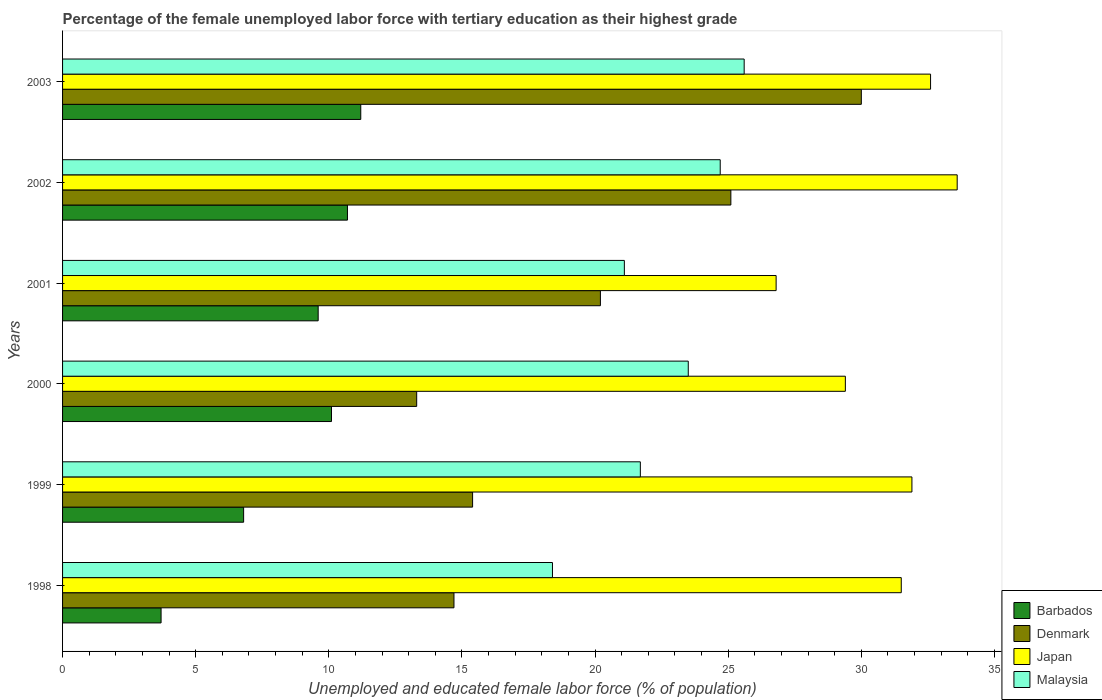How many different coloured bars are there?
Your answer should be compact. 4. Are the number of bars on each tick of the Y-axis equal?
Your response must be concise. Yes. How many bars are there on the 2nd tick from the top?
Offer a very short reply. 4. How many bars are there on the 2nd tick from the bottom?
Ensure brevity in your answer.  4. What is the percentage of the unemployed female labor force with tertiary education in Malaysia in 2003?
Make the answer very short. 25.6. Across all years, what is the maximum percentage of the unemployed female labor force with tertiary education in Japan?
Your answer should be very brief. 33.6. Across all years, what is the minimum percentage of the unemployed female labor force with tertiary education in Malaysia?
Offer a terse response. 18.4. In which year was the percentage of the unemployed female labor force with tertiary education in Denmark minimum?
Provide a short and direct response. 2000. What is the total percentage of the unemployed female labor force with tertiary education in Malaysia in the graph?
Give a very brief answer. 135. What is the difference between the percentage of the unemployed female labor force with tertiary education in Barbados in 2000 and that in 2003?
Keep it short and to the point. -1.1. What is the difference between the percentage of the unemployed female labor force with tertiary education in Japan in 2001 and the percentage of the unemployed female labor force with tertiary education in Denmark in 2003?
Offer a terse response. -3.2. What is the average percentage of the unemployed female labor force with tertiary education in Barbados per year?
Provide a short and direct response. 8.68. In the year 2002, what is the difference between the percentage of the unemployed female labor force with tertiary education in Denmark and percentage of the unemployed female labor force with tertiary education in Japan?
Your answer should be compact. -8.5. In how many years, is the percentage of the unemployed female labor force with tertiary education in Japan greater than 25 %?
Offer a very short reply. 6. What is the ratio of the percentage of the unemployed female labor force with tertiary education in Malaysia in 1999 to that in 2000?
Offer a very short reply. 0.92. What is the difference between the highest and the second highest percentage of the unemployed female labor force with tertiary education in Barbados?
Provide a short and direct response. 0.5. What is the difference between the highest and the lowest percentage of the unemployed female labor force with tertiary education in Barbados?
Your response must be concise. 7.5. In how many years, is the percentage of the unemployed female labor force with tertiary education in Denmark greater than the average percentage of the unemployed female labor force with tertiary education in Denmark taken over all years?
Provide a short and direct response. 3. Is the sum of the percentage of the unemployed female labor force with tertiary education in Barbados in 2001 and 2002 greater than the maximum percentage of the unemployed female labor force with tertiary education in Denmark across all years?
Offer a very short reply. No. Is it the case that in every year, the sum of the percentage of the unemployed female labor force with tertiary education in Barbados and percentage of the unemployed female labor force with tertiary education in Denmark is greater than the sum of percentage of the unemployed female labor force with tertiary education in Malaysia and percentage of the unemployed female labor force with tertiary education in Japan?
Make the answer very short. No. What does the 2nd bar from the bottom in 1999 represents?
Make the answer very short. Denmark. How many bars are there?
Your answer should be very brief. 24. Are all the bars in the graph horizontal?
Keep it short and to the point. Yes. What is the difference between two consecutive major ticks on the X-axis?
Offer a terse response. 5. Are the values on the major ticks of X-axis written in scientific E-notation?
Make the answer very short. No. Does the graph contain grids?
Your answer should be very brief. No. Where does the legend appear in the graph?
Keep it short and to the point. Bottom right. What is the title of the graph?
Your answer should be very brief. Percentage of the female unemployed labor force with tertiary education as their highest grade. What is the label or title of the X-axis?
Offer a very short reply. Unemployed and educated female labor force (% of population). What is the label or title of the Y-axis?
Keep it short and to the point. Years. What is the Unemployed and educated female labor force (% of population) of Barbados in 1998?
Your answer should be compact. 3.7. What is the Unemployed and educated female labor force (% of population) of Denmark in 1998?
Make the answer very short. 14.7. What is the Unemployed and educated female labor force (% of population) in Japan in 1998?
Your response must be concise. 31.5. What is the Unemployed and educated female labor force (% of population) of Malaysia in 1998?
Your answer should be compact. 18.4. What is the Unemployed and educated female labor force (% of population) of Barbados in 1999?
Your answer should be compact. 6.8. What is the Unemployed and educated female labor force (% of population) of Denmark in 1999?
Offer a terse response. 15.4. What is the Unemployed and educated female labor force (% of population) of Japan in 1999?
Provide a short and direct response. 31.9. What is the Unemployed and educated female labor force (% of population) of Malaysia in 1999?
Make the answer very short. 21.7. What is the Unemployed and educated female labor force (% of population) of Barbados in 2000?
Give a very brief answer. 10.1. What is the Unemployed and educated female labor force (% of population) in Denmark in 2000?
Your answer should be very brief. 13.3. What is the Unemployed and educated female labor force (% of population) of Japan in 2000?
Offer a terse response. 29.4. What is the Unemployed and educated female labor force (% of population) of Malaysia in 2000?
Your answer should be very brief. 23.5. What is the Unemployed and educated female labor force (% of population) of Barbados in 2001?
Offer a very short reply. 9.6. What is the Unemployed and educated female labor force (% of population) of Denmark in 2001?
Your answer should be compact. 20.2. What is the Unemployed and educated female labor force (% of population) in Japan in 2001?
Ensure brevity in your answer.  26.8. What is the Unemployed and educated female labor force (% of population) in Malaysia in 2001?
Provide a short and direct response. 21.1. What is the Unemployed and educated female labor force (% of population) of Barbados in 2002?
Your answer should be very brief. 10.7. What is the Unemployed and educated female labor force (% of population) of Denmark in 2002?
Provide a short and direct response. 25.1. What is the Unemployed and educated female labor force (% of population) in Japan in 2002?
Your response must be concise. 33.6. What is the Unemployed and educated female labor force (% of population) of Malaysia in 2002?
Offer a very short reply. 24.7. What is the Unemployed and educated female labor force (% of population) of Barbados in 2003?
Your answer should be compact. 11.2. What is the Unemployed and educated female labor force (% of population) of Denmark in 2003?
Make the answer very short. 30. What is the Unemployed and educated female labor force (% of population) in Japan in 2003?
Give a very brief answer. 32.6. What is the Unemployed and educated female labor force (% of population) in Malaysia in 2003?
Provide a short and direct response. 25.6. Across all years, what is the maximum Unemployed and educated female labor force (% of population) in Barbados?
Offer a terse response. 11.2. Across all years, what is the maximum Unemployed and educated female labor force (% of population) of Denmark?
Give a very brief answer. 30. Across all years, what is the maximum Unemployed and educated female labor force (% of population) of Japan?
Give a very brief answer. 33.6. Across all years, what is the maximum Unemployed and educated female labor force (% of population) of Malaysia?
Ensure brevity in your answer.  25.6. Across all years, what is the minimum Unemployed and educated female labor force (% of population) of Barbados?
Your response must be concise. 3.7. Across all years, what is the minimum Unemployed and educated female labor force (% of population) of Denmark?
Your answer should be very brief. 13.3. Across all years, what is the minimum Unemployed and educated female labor force (% of population) of Japan?
Give a very brief answer. 26.8. Across all years, what is the minimum Unemployed and educated female labor force (% of population) in Malaysia?
Your answer should be compact. 18.4. What is the total Unemployed and educated female labor force (% of population) in Barbados in the graph?
Provide a succinct answer. 52.1. What is the total Unemployed and educated female labor force (% of population) in Denmark in the graph?
Your response must be concise. 118.7. What is the total Unemployed and educated female labor force (% of population) of Japan in the graph?
Your response must be concise. 185.8. What is the total Unemployed and educated female labor force (% of population) in Malaysia in the graph?
Your response must be concise. 135. What is the difference between the Unemployed and educated female labor force (% of population) in Denmark in 1998 and that in 1999?
Your answer should be compact. -0.7. What is the difference between the Unemployed and educated female labor force (% of population) in Japan in 1998 and that in 1999?
Give a very brief answer. -0.4. What is the difference between the Unemployed and educated female labor force (% of population) in Barbados in 1998 and that in 2000?
Provide a short and direct response. -6.4. What is the difference between the Unemployed and educated female labor force (% of population) of Denmark in 1998 and that in 2000?
Give a very brief answer. 1.4. What is the difference between the Unemployed and educated female labor force (% of population) of Malaysia in 1998 and that in 2000?
Ensure brevity in your answer.  -5.1. What is the difference between the Unemployed and educated female labor force (% of population) in Denmark in 1998 and that in 2001?
Your answer should be compact. -5.5. What is the difference between the Unemployed and educated female labor force (% of population) in Japan in 1998 and that in 2001?
Make the answer very short. 4.7. What is the difference between the Unemployed and educated female labor force (% of population) of Malaysia in 1998 and that in 2001?
Your answer should be compact. -2.7. What is the difference between the Unemployed and educated female labor force (% of population) of Barbados in 1998 and that in 2002?
Offer a terse response. -7. What is the difference between the Unemployed and educated female labor force (% of population) in Denmark in 1998 and that in 2002?
Your answer should be compact. -10.4. What is the difference between the Unemployed and educated female labor force (% of population) of Japan in 1998 and that in 2002?
Offer a very short reply. -2.1. What is the difference between the Unemployed and educated female labor force (% of population) of Denmark in 1998 and that in 2003?
Ensure brevity in your answer.  -15.3. What is the difference between the Unemployed and educated female labor force (% of population) of Japan in 1999 and that in 2000?
Ensure brevity in your answer.  2.5. What is the difference between the Unemployed and educated female labor force (% of population) in Japan in 1999 and that in 2001?
Offer a terse response. 5.1. What is the difference between the Unemployed and educated female labor force (% of population) of Malaysia in 1999 and that in 2001?
Keep it short and to the point. 0.6. What is the difference between the Unemployed and educated female labor force (% of population) in Denmark in 1999 and that in 2002?
Ensure brevity in your answer.  -9.7. What is the difference between the Unemployed and educated female labor force (% of population) in Malaysia in 1999 and that in 2002?
Your answer should be compact. -3. What is the difference between the Unemployed and educated female labor force (% of population) in Barbados in 1999 and that in 2003?
Provide a short and direct response. -4.4. What is the difference between the Unemployed and educated female labor force (% of population) of Denmark in 1999 and that in 2003?
Give a very brief answer. -14.6. What is the difference between the Unemployed and educated female labor force (% of population) in Japan in 1999 and that in 2003?
Provide a succinct answer. -0.7. What is the difference between the Unemployed and educated female labor force (% of population) of Malaysia in 1999 and that in 2003?
Ensure brevity in your answer.  -3.9. What is the difference between the Unemployed and educated female labor force (% of population) in Denmark in 2000 and that in 2001?
Your answer should be compact. -6.9. What is the difference between the Unemployed and educated female labor force (% of population) in Japan in 2000 and that in 2001?
Ensure brevity in your answer.  2.6. What is the difference between the Unemployed and educated female labor force (% of population) in Malaysia in 2000 and that in 2001?
Your response must be concise. 2.4. What is the difference between the Unemployed and educated female labor force (% of population) of Denmark in 2000 and that in 2002?
Your response must be concise. -11.8. What is the difference between the Unemployed and educated female labor force (% of population) of Japan in 2000 and that in 2002?
Provide a short and direct response. -4.2. What is the difference between the Unemployed and educated female labor force (% of population) in Malaysia in 2000 and that in 2002?
Offer a terse response. -1.2. What is the difference between the Unemployed and educated female labor force (% of population) of Denmark in 2000 and that in 2003?
Ensure brevity in your answer.  -16.7. What is the difference between the Unemployed and educated female labor force (% of population) in Japan in 2000 and that in 2003?
Offer a very short reply. -3.2. What is the difference between the Unemployed and educated female labor force (% of population) in Malaysia in 2000 and that in 2003?
Keep it short and to the point. -2.1. What is the difference between the Unemployed and educated female labor force (% of population) of Barbados in 2001 and that in 2002?
Provide a short and direct response. -1.1. What is the difference between the Unemployed and educated female labor force (% of population) in Japan in 2001 and that in 2002?
Offer a terse response. -6.8. What is the difference between the Unemployed and educated female labor force (% of population) in Barbados in 2001 and that in 2003?
Your response must be concise. -1.6. What is the difference between the Unemployed and educated female labor force (% of population) in Denmark in 2001 and that in 2003?
Give a very brief answer. -9.8. What is the difference between the Unemployed and educated female labor force (% of population) in Malaysia in 2001 and that in 2003?
Make the answer very short. -4.5. What is the difference between the Unemployed and educated female labor force (% of population) in Barbados in 2002 and that in 2003?
Offer a terse response. -0.5. What is the difference between the Unemployed and educated female labor force (% of population) of Denmark in 2002 and that in 2003?
Keep it short and to the point. -4.9. What is the difference between the Unemployed and educated female labor force (% of population) of Barbados in 1998 and the Unemployed and educated female labor force (% of population) of Japan in 1999?
Your response must be concise. -28.2. What is the difference between the Unemployed and educated female labor force (% of population) of Denmark in 1998 and the Unemployed and educated female labor force (% of population) of Japan in 1999?
Provide a succinct answer. -17.2. What is the difference between the Unemployed and educated female labor force (% of population) in Japan in 1998 and the Unemployed and educated female labor force (% of population) in Malaysia in 1999?
Your answer should be very brief. 9.8. What is the difference between the Unemployed and educated female labor force (% of population) in Barbados in 1998 and the Unemployed and educated female labor force (% of population) in Japan in 2000?
Offer a terse response. -25.7. What is the difference between the Unemployed and educated female labor force (% of population) in Barbados in 1998 and the Unemployed and educated female labor force (% of population) in Malaysia in 2000?
Provide a succinct answer. -19.8. What is the difference between the Unemployed and educated female labor force (% of population) in Denmark in 1998 and the Unemployed and educated female labor force (% of population) in Japan in 2000?
Offer a very short reply. -14.7. What is the difference between the Unemployed and educated female labor force (% of population) in Japan in 1998 and the Unemployed and educated female labor force (% of population) in Malaysia in 2000?
Keep it short and to the point. 8. What is the difference between the Unemployed and educated female labor force (% of population) of Barbados in 1998 and the Unemployed and educated female labor force (% of population) of Denmark in 2001?
Give a very brief answer. -16.5. What is the difference between the Unemployed and educated female labor force (% of population) in Barbados in 1998 and the Unemployed and educated female labor force (% of population) in Japan in 2001?
Offer a very short reply. -23.1. What is the difference between the Unemployed and educated female labor force (% of population) in Barbados in 1998 and the Unemployed and educated female labor force (% of population) in Malaysia in 2001?
Make the answer very short. -17.4. What is the difference between the Unemployed and educated female labor force (% of population) in Japan in 1998 and the Unemployed and educated female labor force (% of population) in Malaysia in 2001?
Provide a succinct answer. 10.4. What is the difference between the Unemployed and educated female labor force (% of population) of Barbados in 1998 and the Unemployed and educated female labor force (% of population) of Denmark in 2002?
Your answer should be compact. -21.4. What is the difference between the Unemployed and educated female labor force (% of population) of Barbados in 1998 and the Unemployed and educated female labor force (% of population) of Japan in 2002?
Provide a short and direct response. -29.9. What is the difference between the Unemployed and educated female labor force (% of population) in Denmark in 1998 and the Unemployed and educated female labor force (% of population) in Japan in 2002?
Offer a very short reply. -18.9. What is the difference between the Unemployed and educated female labor force (% of population) in Japan in 1998 and the Unemployed and educated female labor force (% of population) in Malaysia in 2002?
Your answer should be compact. 6.8. What is the difference between the Unemployed and educated female labor force (% of population) in Barbados in 1998 and the Unemployed and educated female labor force (% of population) in Denmark in 2003?
Make the answer very short. -26.3. What is the difference between the Unemployed and educated female labor force (% of population) of Barbados in 1998 and the Unemployed and educated female labor force (% of population) of Japan in 2003?
Offer a terse response. -28.9. What is the difference between the Unemployed and educated female labor force (% of population) in Barbados in 1998 and the Unemployed and educated female labor force (% of population) in Malaysia in 2003?
Provide a short and direct response. -21.9. What is the difference between the Unemployed and educated female labor force (% of population) of Denmark in 1998 and the Unemployed and educated female labor force (% of population) of Japan in 2003?
Provide a succinct answer. -17.9. What is the difference between the Unemployed and educated female labor force (% of population) of Japan in 1998 and the Unemployed and educated female labor force (% of population) of Malaysia in 2003?
Provide a succinct answer. 5.9. What is the difference between the Unemployed and educated female labor force (% of population) of Barbados in 1999 and the Unemployed and educated female labor force (% of population) of Japan in 2000?
Offer a very short reply. -22.6. What is the difference between the Unemployed and educated female labor force (% of population) in Barbados in 1999 and the Unemployed and educated female labor force (% of population) in Malaysia in 2000?
Keep it short and to the point. -16.7. What is the difference between the Unemployed and educated female labor force (% of population) in Denmark in 1999 and the Unemployed and educated female labor force (% of population) in Japan in 2000?
Provide a short and direct response. -14. What is the difference between the Unemployed and educated female labor force (% of population) in Japan in 1999 and the Unemployed and educated female labor force (% of population) in Malaysia in 2000?
Your answer should be compact. 8.4. What is the difference between the Unemployed and educated female labor force (% of population) of Barbados in 1999 and the Unemployed and educated female labor force (% of population) of Japan in 2001?
Provide a short and direct response. -20. What is the difference between the Unemployed and educated female labor force (% of population) of Barbados in 1999 and the Unemployed and educated female labor force (% of population) of Malaysia in 2001?
Provide a succinct answer. -14.3. What is the difference between the Unemployed and educated female labor force (% of population) of Denmark in 1999 and the Unemployed and educated female labor force (% of population) of Japan in 2001?
Your answer should be very brief. -11.4. What is the difference between the Unemployed and educated female labor force (% of population) in Denmark in 1999 and the Unemployed and educated female labor force (% of population) in Malaysia in 2001?
Provide a short and direct response. -5.7. What is the difference between the Unemployed and educated female labor force (% of population) in Japan in 1999 and the Unemployed and educated female labor force (% of population) in Malaysia in 2001?
Make the answer very short. 10.8. What is the difference between the Unemployed and educated female labor force (% of population) of Barbados in 1999 and the Unemployed and educated female labor force (% of population) of Denmark in 2002?
Provide a short and direct response. -18.3. What is the difference between the Unemployed and educated female labor force (% of population) in Barbados in 1999 and the Unemployed and educated female labor force (% of population) in Japan in 2002?
Offer a terse response. -26.8. What is the difference between the Unemployed and educated female labor force (% of population) in Barbados in 1999 and the Unemployed and educated female labor force (% of population) in Malaysia in 2002?
Your answer should be compact. -17.9. What is the difference between the Unemployed and educated female labor force (% of population) of Denmark in 1999 and the Unemployed and educated female labor force (% of population) of Japan in 2002?
Your answer should be compact. -18.2. What is the difference between the Unemployed and educated female labor force (% of population) of Denmark in 1999 and the Unemployed and educated female labor force (% of population) of Malaysia in 2002?
Provide a succinct answer. -9.3. What is the difference between the Unemployed and educated female labor force (% of population) in Barbados in 1999 and the Unemployed and educated female labor force (% of population) in Denmark in 2003?
Your answer should be compact. -23.2. What is the difference between the Unemployed and educated female labor force (% of population) in Barbados in 1999 and the Unemployed and educated female labor force (% of population) in Japan in 2003?
Offer a terse response. -25.8. What is the difference between the Unemployed and educated female labor force (% of population) of Barbados in 1999 and the Unemployed and educated female labor force (% of population) of Malaysia in 2003?
Your response must be concise. -18.8. What is the difference between the Unemployed and educated female labor force (% of population) of Denmark in 1999 and the Unemployed and educated female labor force (% of population) of Japan in 2003?
Ensure brevity in your answer.  -17.2. What is the difference between the Unemployed and educated female labor force (% of population) of Barbados in 2000 and the Unemployed and educated female labor force (% of population) of Japan in 2001?
Your answer should be compact. -16.7. What is the difference between the Unemployed and educated female labor force (% of population) in Barbados in 2000 and the Unemployed and educated female labor force (% of population) in Malaysia in 2001?
Provide a succinct answer. -11. What is the difference between the Unemployed and educated female labor force (% of population) of Denmark in 2000 and the Unemployed and educated female labor force (% of population) of Malaysia in 2001?
Give a very brief answer. -7.8. What is the difference between the Unemployed and educated female labor force (% of population) in Barbados in 2000 and the Unemployed and educated female labor force (% of population) in Denmark in 2002?
Keep it short and to the point. -15. What is the difference between the Unemployed and educated female labor force (% of population) of Barbados in 2000 and the Unemployed and educated female labor force (% of population) of Japan in 2002?
Your answer should be very brief. -23.5. What is the difference between the Unemployed and educated female labor force (% of population) of Barbados in 2000 and the Unemployed and educated female labor force (% of population) of Malaysia in 2002?
Your answer should be compact. -14.6. What is the difference between the Unemployed and educated female labor force (% of population) of Denmark in 2000 and the Unemployed and educated female labor force (% of population) of Japan in 2002?
Keep it short and to the point. -20.3. What is the difference between the Unemployed and educated female labor force (% of population) of Barbados in 2000 and the Unemployed and educated female labor force (% of population) of Denmark in 2003?
Offer a terse response. -19.9. What is the difference between the Unemployed and educated female labor force (% of population) of Barbados in 2000 and the Unemployed and educated female labor force (% of population) of Japan in 2003?
Your answer should be compact. -22.5. What is the difference between the Unemployed and educated female labor force (% of population) of Barbados in 2000 and the Unemployed and educated female labor force (% of population) of Malaysia in 2003?
Make the answer very short. -15.5. What is the difference between the Unemployed and educated female labor force (% of population) in Denmark in 2000 and the Unemployed and educated female labor force (% of population) in Japan in 2003?
Make the answer very short. -19.3. What is the difference between the Unemployed and educated female labor force (% of population) in Denmark in 2000 and the Unemployed and educated female labor force (% of population) in Malaysia in 2003?
Your response must be concise. -12.3. What is the difference between the Unemployed and educated female labor force (% of population) of Barbados in 2001 and the Unemployed and educated female labor force (% of population) of Denmark in 2002?
Make the answer very short. -15.5. What is the difference between the Unemployed and educated female labor force (% of population) in Barbados in 2001 and the Unemployed and educated female labor force (% of population) in Japan in 2002?
Give a very brief answer. -24. What is the difference between the Unemployed and educated female labor force (% of population) of Barbados in 2001 and the Unemployed and educated female labor force (% of population) of Malaysia in 2002?
Offer a terse response. -15.1. What is the difference between the Unemployed and educated female labor force (% of population) of Denmark in 2001 and the Unemployed and educated female labor force (% of population) of Japan in 2002?
Ensure brevity in your answer.  -13.4. What is the difference between the Unemployed and educated female labor force (% of population) of Denmark in 2001 and the Unemployed and educated female labor force (% of population) of Malaysia in 2002?
Give a very brief answer. -4.5. What is the difference between the Unemployed and educated female labor force (% of population) in Barbados in 2001 and the Unemployed and educated female labor force (% of population) in Denmark in 2003?
Provide a short and direct response. -20.4. What is the difference between the Unemployed and educated female labor force (% of population) of Barbados in 2001 and the Unemployed and educated female labor force (% of population) of Malaysia in 2003?
Offer a terse response. -16. What is the difference between the Unemployed and educated female labor force (% of population) in Denmark in 2001 and the Unemployed and educated female labor force (% of population) in Japan in 2003?
Your answer should be very brief. -12.4. What is the difference between the Unemployed and educated female labor force (% of population) in Japan in 2001 and the Unemployed and educated female labor force (% of population) in Malaysia in 2003?
Keep it short and to the point. 1.2. What is the difference between the Unemployed and educated female labor force (% of population) of Barbados in 2002 and the Unemployed and educated female labor force (% of population) of Denmark in 2003?
Ensure brevity in your answer.  -19.3. What is the difference between the Unemployed and educated female labor force (% of population) in Barbados in 2002 and the Unemployed and educated female labor force (% of population) in Japan in 2003?
Give a very brief answer. -21.9. What is the difference between the Unemployed and educated female labor force (% of population) of Barbados in 2002 and the Unemployed and educated female labor force (% of population) of Malaysia in 2003?
Offer a terse response. -14.9. What is the difference between the Unemployed and educated female labor force (% of population) of Denmark in 2002 and the Unemployed and educated female labor force (% of population) of Japan in 2003?
Your response must be concise. -7.5. What is the difference between the Unemployed and educated female labor force (% of population) in Japan in 2002 and the Unemployed and educated female labor force (% of population) in Malaysia in 2003?
Your answer should be very brief. 8. What is the average Unemployed and educated female labor force (% of population) in Barbados per year?
Your response must be concise. 8.68. What is the average Unemployed and educated female labor force (% of population) in Denmark per year?
Your answer should be compact. 19.78. What is the average Unemployed and educated female labor force (% of population) in Japan per year?
Offer a terse response. 30.97. In the year 1998, what is the difference between the Unemployed and educated female labor force (% of population) of Barbados and Unemployed and educated female labor force (% of population) of Japan?
Ensure brevity in your answer.  -27.8. In the year 1998, what is the difference between the Unemployed and educated female labor force (% of population) of Barbados and Unemployed and educated female labor force (% of population) of Malaysia?
Provide a short and direct response. -14.7. In the year 1998, what is the difference between the Unemployed and educated female labor force (% of population) in Denmark and Unemployed and educated female labor force (% of population) in Japan?
Your answer should be very brief. -16.8. In the year 1998, what is the difference between the Unemployed and educated female labor force (% of population) of Denmark and Unemployed and educated female labor force (% of population) of Malaysia?
Offer a terse response. -3.7. In the year 1999, what is the difference between the Unemployed and educated female labor force (% of population) of Barbados and Unemployed and educated female labor force (% of population) of Japan?
Your answer should be compact. -25.1. In the year 1999, what is the difference between the Unemployed and educated female labor force (% of population) in Barbados and Unemployed and educated female labor force (% of population) in Malaysia?
Make the answer very short. -14.9. In the year 1999, what is the difference between the Unemployed and educated female labor force (% of population) in Denmark and Unemployed and educated female labor force (% of population) in Japan?
Offer a terse response. -16.5. In the year 1999, what is the difference between the Unemployed and educated female labor force (% of population) in Denmark and Unemployed and educated female labor force (% of population) in Malaysia?
Offer a terse response. -6.3. In the year 1999, what is the difference between the Unemployed and educated female labor force (% of population) of Japan and Unemployed and educated female labor force (% of population) of Malaysia?
Ensure brevity in your answer.  10.2. In the year 2000, what is the difference between the Unemployed and educated female labor force (% of population) in Barbados and Unemployed and educated female labor force (% of population) in Japan?
Provide a succinct answer. -19.3. In the year 2000, what is the difference between the Unemployed and educated female labor force (% of population) of Denmark and Unemployed and educated female labor force (% of population) of Japan?
Ensure brevity in your answer.  -16.1. In the year 2000, what is the difference between the Unemployed and educated female labor force (% of population) of Japan and Unemployed and educated female labor force (% of population) of Malaysia?
Provide a succinct answer. 5.9. In the year 2001, what is the difference between the Unemployed and educated female labor force (% of population) of Barbados and Unemployed and educated female labor force (% of population) of Japan?
Your answer should be compact. -17.2. In the year 2001, what is the difference between the Unemployed and educated female labor force (% of population) in Denmark and Unemployed and educated female labor force (% of population) in Japan?
Offer a terse response. -6.6. In the year 2001, what is the difference between the Unemployed and educated female labor force (% of population) in Denmark and Unemployed and educated female labor force (% of population) in Malaysia?
Provide a short and direct response. -0.9. In the year 2001, what is the difference between the Unemployed and educated female labor force (% of population) of Japan and Unemployed and educated female labor force (% of population) of Malaysia?
Provide a short and direct response. 5.7. In the year 2002, what is the difference between the Unemployed and educated female labor force (% of population) in Barbados and Unemployed and educated female labor force (% of population) in Denmark?
Ensure brevity in your answer.  -14.4. In the year 2002, what is the difference between the Unemployed and educated female labor force (% of population) in Barbados and Unemployed and educated female labor force (% of population) in Japan?
Ensure brevity in your answer.  -22.9. In the year 2002, what is the difference between the Unemployed and educated female labor force (% of population) in Denmark and Unemployed and educated female labor force (% of population) in Malaysia?
Your response must be concise. 0.4. In the year 2002, what is the difference between the Unemployed and educated female labor force (% of population) in Japan and Unemployed and educated female labor force (% of population) in Malaysia?
Provide a short and direct response. 8.9. In the year 2003, what is the difference between the Unemployed and educated female labor force (% of population) in Barbados and Unemployed and educated female labor force (% of population) in Denmark?
Provide a succinct answer. -18.8. In the year 2003, what is the difference between the Unemployed and educated female labor force (% of population) of Barbados and Unemployed and educated female labor force (% of population) of Japan?
Give a very brief answer. -21.4. In the year 2003, what is the difference between the Unemployed and educated female labor force (% of population) in Barbados and Unemployed and educated female labor force (% of population) in Malaysia?
Keep it short and to the point. -14.4. In the year 2003, what is the difference between the Unemployed and educated female labor force (% of population) in Denmark and Unemployed and educated female labor force (% of population) in Japan?
Ensure brevity in your answer.  -2.6. In the year 2003, what is the difference between the Unemployed and educated female labor force (% of population) of Denmark and Unemployed and educated female labor force (% of population) of Malaysia?
Provide a short and direct response. 4.4. What is the ratio of the Unemployed and educated female labor force (% of population) in Barbados in 1998 to that in 1999?
Ensure brevity in your answer.  0.54. What is the ratio of the Unemployed and educated female labor force (% of population) in Denmark in 1998 to that in 1999?
Give a very brief answer. 0.95. What is the ratio of the Unemployed and educated female labor force (% of population) in Japan in 1998 to that in 1999?
Keep it short and to the point. 0.99. What is the ratio of the Unemployed and educated female labor force (% of population) of Malaysia in 1998 to that in 1999?
Your response must be concise. 0.85. What is the ratio of the Unemployed and educated female labor force (% of population) in Barbados in 1998 to that in 2000?
Provide a succinct answer. 0.37. What is the ratio of the Unemployed and educated female labor force (% of population) in Denmark in 1998 to that in 2000?
Ensure brevity in your answer.  1.11. What is the ratio of the Unemployed and educated female labor force (% of population) in Japan in 1998 to that in 2000?
Offer a terse response. 1.07. What is the ratio of the Unemployed and educated female labor force (% of population) of Malaysia in 1998 to that in 2000?
Provide a succinct answer. 0.78. What is the ratio of the Unemployed and educated female labor force (% of population) of Barbados in 1998 to that in 2001?
Your answer should be very brief. 0.39. What is the ratio of the Unemployed and educated female labor force (% of population) of Denmark in 1998 to that in 2001?
Your answer should be very brief. 0.73. What is the ratio of the Unemployed and educated female labor force (% of population) in Japan in 1998 to that in 2001?
Provide a succinct answer. 1.18. What is the ratio of the Unemployed and educated female labor force (% of population) in Malaysia in 1998 to that in 2001?
Your answer should be very brief. 0.87. What is the ratio of the Unemployed and educated female labor force (% of population) of Barbados in 1998 to that in 2002?
Make the answer very short. 0.35. What is the ratio of the Unemployed and educated female labor force (% of population) of Denmark in 1998 to that in 2002?
Your answer should be compact. 0.59. What is the ratio of the Unemployed and educated female labor force (% of population) in Malaysia in 1998 to that in 2002?
Provide a succinct answer. 0.74. What is the ratio of the Unemployed and educated female labor force (% of population) in Barbados in 1998 to that in 2003?
Keep it short and to the point. 0.33. What is the ratio of the Unemployed and educated female labor force (% of population) of Denmark in 1998 to that in 2003?
Ensure brevity in your answer.  0.49. What is the ratio of the Unemployed and educated female labor force (% of population) in Japan in 1998 to that in 2003?
Keep it short and to the point. 0.97. What is the ratio of the Unemployed and educated female labor force (% of population) in Malaysia in 1998 to that in 2003?
Your answer should be compact. 0.72. What is the ratio of the Unemployed and educated female labor force (% of population) of Barbados in 1999 to that in 2000?
Give a very brief answer. 0.67. What is the ratio of the Unemployed and educated female labor force (% of population) of Denmark in 1999 to that in 2000?
Make the answer very short. 1.16. What is the ratio of the Unemployed and educated female labor force (% of population) in Japan in 1999 to that in 2000?
Give a very brief answer. 1.08. What is the ratio of the Unemployed and educated female labor force (% of population) in Malaysia in 1999 to that in 2000?
Keep it short and to the point. 0.92. What is the ratio of the Unemployed and educated female labor force (% of population) of Barbados in 1999 to that in 2001?
Keep it short and to the point. 0.71. What is the ratio of the Unemployed and educated female labor force (% of population) of Denmark in 1999 to that in 2001?
Offer a very short reply. 0.76. What is the ratio of the Unemployed and educated female labor force (% of population) of Japan in 1999 to that in 2001?
Offer a very short reply. 1.19. What is the ratio of the Unemployed and educated female labor force (% of population) of Malaysia in 1999 to that in 2001?
Offer a very short reply. 1.03. What is the ratio of the Unemployed and educated female labor force (% of population) of Barbados in 1999 to that in 2002?
Make the answer very short. 0.64. What is the ratio of the Unemployed and educated female labor force (% of population) of Denmark in 1999 to that in 2002?
Provide a short and direct response. 0.61. What is the ratio of the Unemployed and educated female labor force (% of population) of Japan in 1999 to that in 2002?
Make the answer very short. 0.95. What is the ratio of the Unemployed and educated female labor force (% of population) of Malaysia in 1999 to that in 2002?
Give a very brief answer. 0.88. What is the ratio of the Unemployed and educated female labor force (% of population) of Barbados in 1999 to that in 2003?
Your answer should be very brief. 0.61. What is the ratio of the Unemployed and educated female labor force (% of population) of Denmark in 1999 to that in 2003?
Your answer should be compact. 0.51. What is the ratio of the Unemployed and educated female labor force (% of population) of Japan in 1999 to that in 2003?
Provide a short and direct response. 0.98. What is the ratio of the Unemployed and educated female labor force (% of population) of Malaysia in 1999 to that in 2003?
Keep it short and to the point. 0.85. What is the ratio of the Unemployed and educated female labor force (% of population) of Barbados in 2000 to that in 2001?
Offer a terse response. 1.05. What is the ratio of the Unemployed and educated female labor force (% of population) in Denmark in 2000 to that in 2001?
Keep it short and to the point. 0.66. What is the ratio of the Unemployed and educated female labor force (% of population) in Japan in 2000 to that in 2001?
Your answer should be very brief. 1.1. What is the ratio of the Unemployed and educated female labor force (% of population) of Malaysia in 2000 to that in 2001?
Provide a succinct answer. 1.11. What is the ratio of the Unemployed and educated female labor force (% of population) of Barbados in 2000 to that in 2002?
Keep it short and to the point. 0.94. What is the ratio of the Unemployed and educated female labor force (% of population) of Denmark in 2000 to that in 2002?
Your response must be concise. 0.53. What is the ratio of the Unemployed and educated female labor force (% of population) in Japan in 2000 to that in 2002?
Offer a terse response. 0.88. What is the ratio of the Unemployed and educated female labor force (% of population) of Malaysia in 2000 to that in 2002?
Keep it short and to the point. 0.95. What is the ratio of the Unemployed and educated female labor force (% of population) in Barbados in 2000 to that in 2003?
Give a very brief answer. 0.9. What is the ratio of the Unemployed and educated female labor force (% of population) of Denmark in 2000 to that in 2003?
Make the answer very short. 0.44. What is the ratio of the Unemployed and educated female labor force (% of population) of Japan in 2000 to that in 2003?
Your answer should be very brief. 0.9. What is the ratio of the Unemployed and educated female labor force (% of population) in Malaysia in 2000 to that in 2003?
Provide a succinct answer. 0.92. What is the ratio of the Unemployed and educated female labor force (% of population) in Barbados in 2001 to that in 2002?
Ensure brevity in your answer.  0.9. What is the ratio of the Unemployed and educated female labor force (% of population) of Denmark in 2001 to that in 2002?
Offer a very short reply. 0.8. What is the ratio of the Unemployed and educated female labor force (% of population) in Japan in 2001 to that in 2002?
Provide a succinct answer. 0.8. What is the ratio of the Unemployed and educated female labor force (% of population) of Malaysia in 2001 to that in 2002?
Your response must be concise. 0.85. What is the ratio of the Unemployed and educated female labor force (% of population) in Denmark in 2001 to that in 2003?
Make the answer very short. 0.67. What is the ratio of the Unemployed and educated female labor force (% of population) in Japan in 2001 to that in 2003?
Your answer should be compact. 0.82. What is the ratio of the Unemployed and educated female labor force (% of population) of Malaysia in 2001 to that in 2003?
Make the answer very short. 0.82. What is the ratio of the Unemployed and educated female labor force (% of population) in Barbados in 2002 to that in 2003?
Make the answer very short. 0.96. What is the ratio of the Unemployed and educated female labor force (% of population) in Denmark in 2002 to that in 2003?
Offer a terse response. 0.84. What is the ratio of the Unemployed and educated female labor force (% of population) in Japan in 2002 to that in 2003?
Your answer should be very brief. 1.03. What is the ratio of the Unemployed and educated female labor force (% of population) of Malaysia in 2002 to that in 2003?
Offer a terse response. 0.96. What is the difference between the highest and the second highest Unemployed and educated female labor force (% of population) in Malaysia?
Keep it short and to the point. 0.9. What is the difference between the highest and the lowest Unemployed and educated female labor force (% of population) in Denmark?
Provide a succinct answer. 16.7. What is the difference between the highest and the lowest Unemployed and educated female labor force (% of population) of Malaysia?
Ensure brevity in your answer.  7.2. 